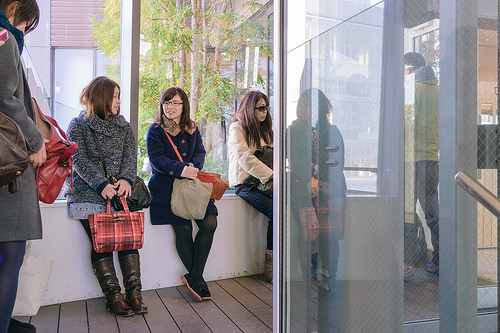<image>
Is there a person behind the reflection? Yes. From this viewpoint, the person is positioned behind the reflection, with the reflection partially or fully occluding the person. 